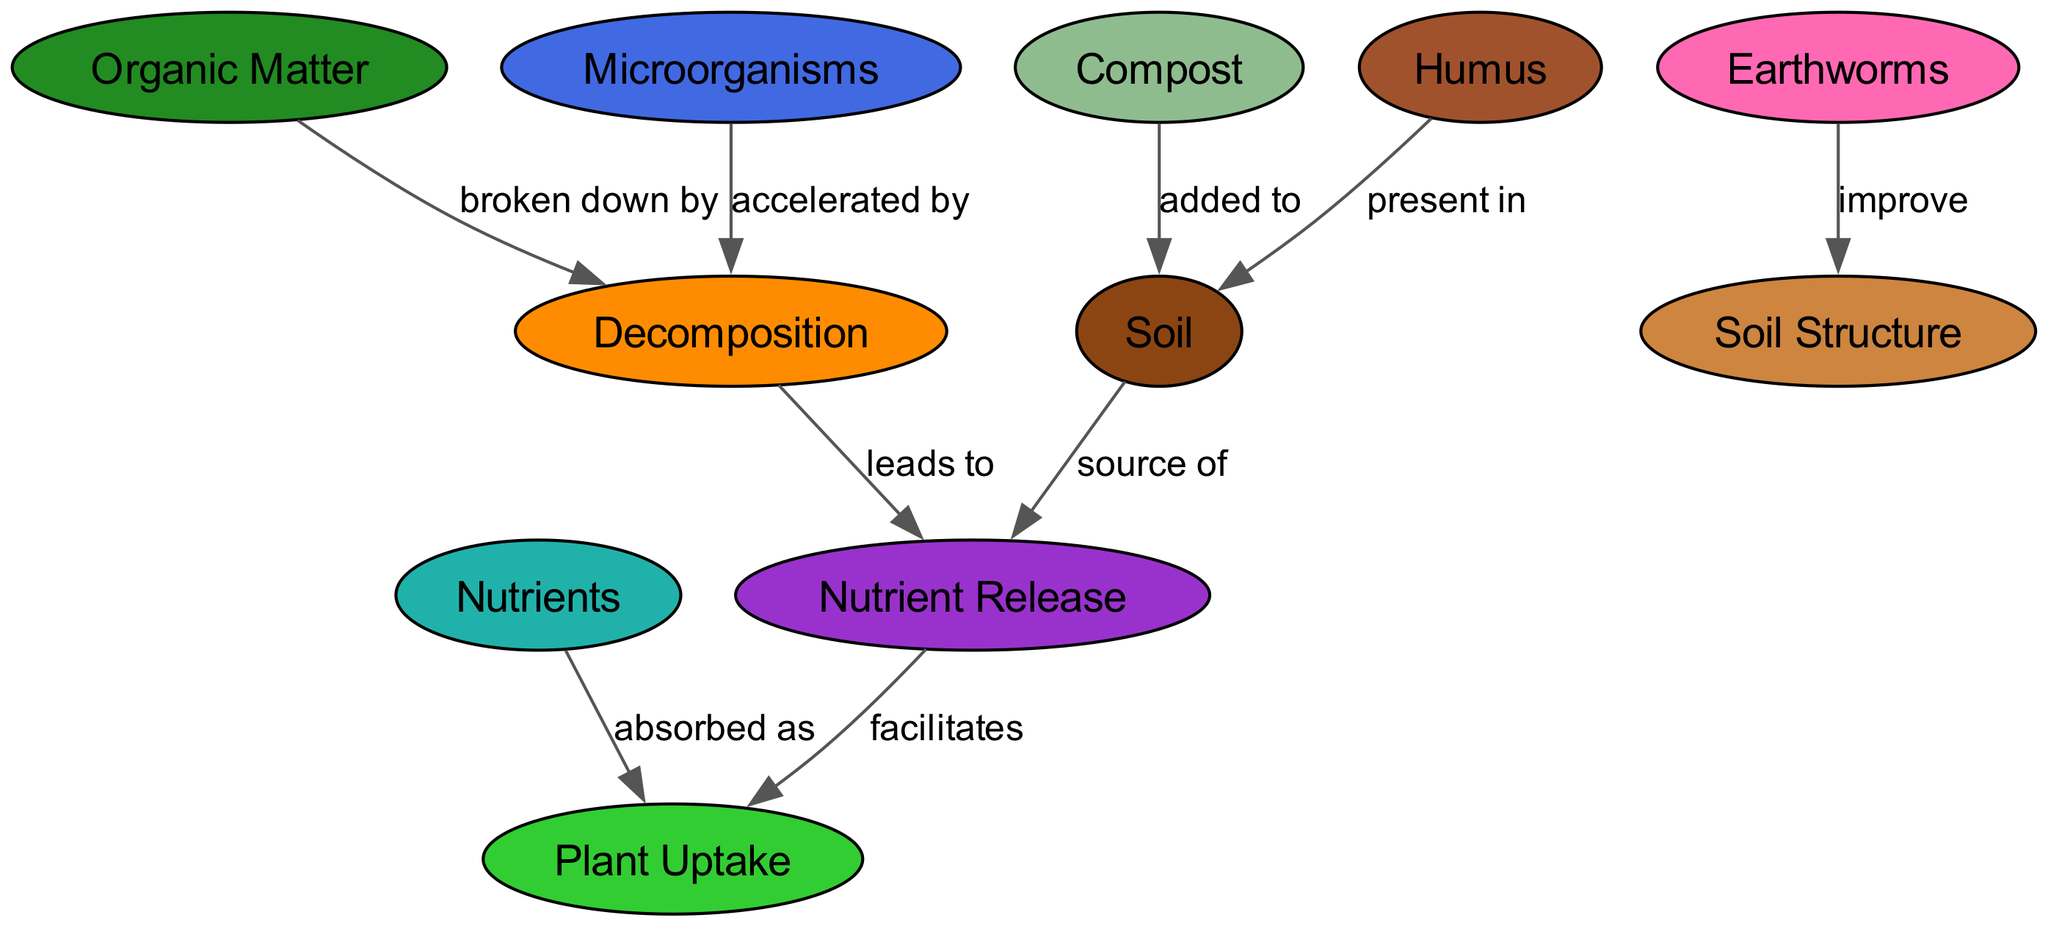What is the primary source of Nutrient Release? The diagram shows that Soil is labeled as the source of Nutrient Release. There is a directed edge from Soil to NutrientRelease indicating this relationship.
Answer: Soil How many nodes are present in the diagram? The diagram contains a total of 11 nodes which represent different components involved in soil composition and nutrient cycling.
Answer: 11 What element is added to Soil? The diagram indicates that Compost is added to Soil. There is a directed edge pointing from Compost to Soil, reflecting this relationship.
Answer: Compost Which two components facilitate Plant Uptake? The diagram shows that Nutrients and Nutrient Release are connected to Plant Uptake. Nutrient Release facilitates Plant Uptake, and Nutrients are also directly absorbed as Plant Uptake.
Answer: Nutrients, Nutrient Release What role do Microorganisms play in Decomposition? According to the diagram, Microorganisms are said to accelerate Decomposition. There is a connection indicating that Microorganisms enhance this process.
Answer: Accelerated by How does Earthworms impact Soil Structure? The diagram illustrates that Earthworms improve Soil Structure. There is a directed edge from Earthworms to Soil Structure reflecting their positive contribution.
Answer: Improve What process leads to Nutrient Release? The relationship in the diagram indicates that Decomposition leads to Nutrient Release, demonstrating a sequential flow from one process to the next.
Answer: Decomposition Which components are present in Soil? The diagram indicates that both Humus and Organic Matter are associated with Soil. Humus is described as being present in Soil while Organic Matter contributes to its composition.
Answer: Humus, Organic Matter How does Compost contribute to the Soil? The diagram specifies that Compost is added to Soil, which suggests that it enriches the soil by providing beneficial organic materials.
Answer: Added to What do Nutrient Release and Plant Uptake describe in the diagram? These components describe a key relationship in nutrient cycling where Nutrient Release facilitates Plant Uptake, showing how nutrients become available for plant absorption.
Answer: Facilitates 